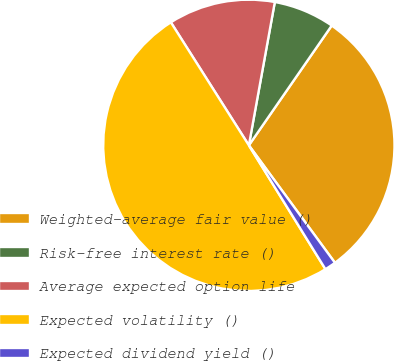Convert chart. <chart><loc_0><loc_0><loc_500><loc_500><pie_chart><fcel>Weighted-average fair value ()<fcel>Risk-free interest rate ()<fcel>Average expected option life<fcel>Expected volatility ()<fcel>Expected dividend yield ()<nl><fcel>30.3%<fcel>6.78%<fcel>11.85%<fcel>49.82%<fcel>1.25%<nl></chart> 